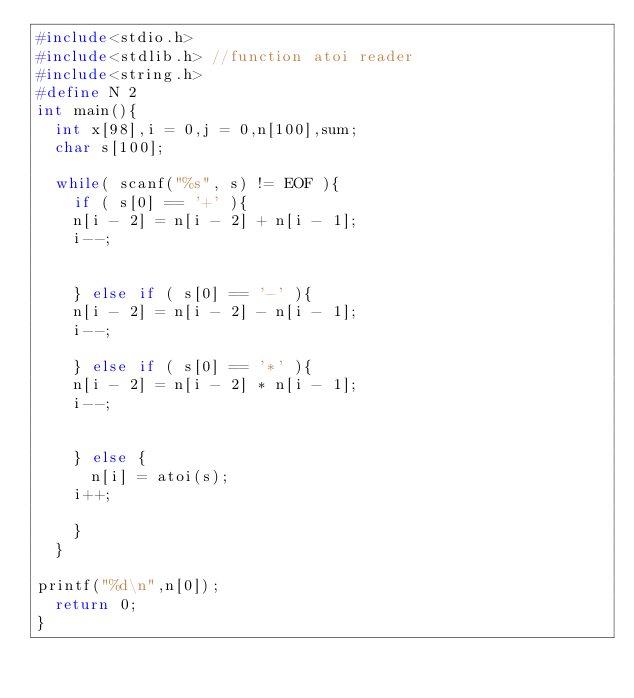<code> <loc_0><loc_0><loc_500><loc_500><_C_>#include<stdio.h>
#include<stdlib.h> //function atoi reader
#include<string.h>
#define N 2
int main(){
  int x[98],i = 0,j = 0,n[100],sum;
  char s[100];
 
  while( scanf("%s", s) != EOF ){
    if ( s[0] == '+' ){
    n[i - 2] = n[i - 2] + n[i - 1];
    i--;
     
 
    } else if ( s[0] == '-' ){
    n[i - 2] = n[i - 2] - n[i - 1];
    i--;
 
    } else if ( s[0] == '*' ){
    n[i - 2] = n[i - 2] * n[i - 1];
    i--;
     
 
    } else {
      n[i] = atoi(s);
    i++;
 
    }
  }
 
printf("%d\n",n[0]);
  return 0;
}</code> 